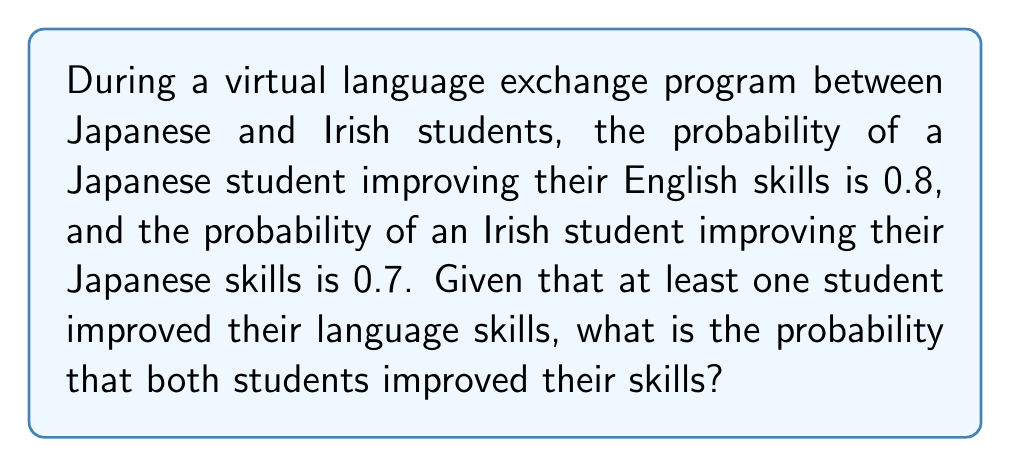Can you solve this math problem? Let's approach this step-by-step:

1) Define events:
   J: Japanese student improves English
   I: Irish student improves Japanese

2) Given probabilities:
   P(J) = 0.8
   P(I) = 0.7

3) We need to find P(J ∩ I | J ∪ I), which is the probability that both improved given that at least one improved.

4) By the definition of conditional probability:

   $$P(J ∩ I | J ∪ I) = \frac{P(J ∩ I)}{P(J ∪ I)}$$

5) Assuming independence between J and I:
   
   $$P(J ∩ I) = P(J) \cdot P(I) = 0.8 \cdot 0.7 = 0.56$$

6) To find P(J ∪ I), we use the addition rule:
   
   $$P(J ∪ I) = P(J) + P(I) - P(J ∩ I)$$
   $$= 0.8 + 0.7 - 0.56 = 0.94$$

7) Now we can calculate the conditional probability:

   $$P(J ∩ I | J ∪ I) = \frac{0.56}{0.94} \approx 0.5957$$
Answer: $\frac{14}{25} \approx 0.5957$ 